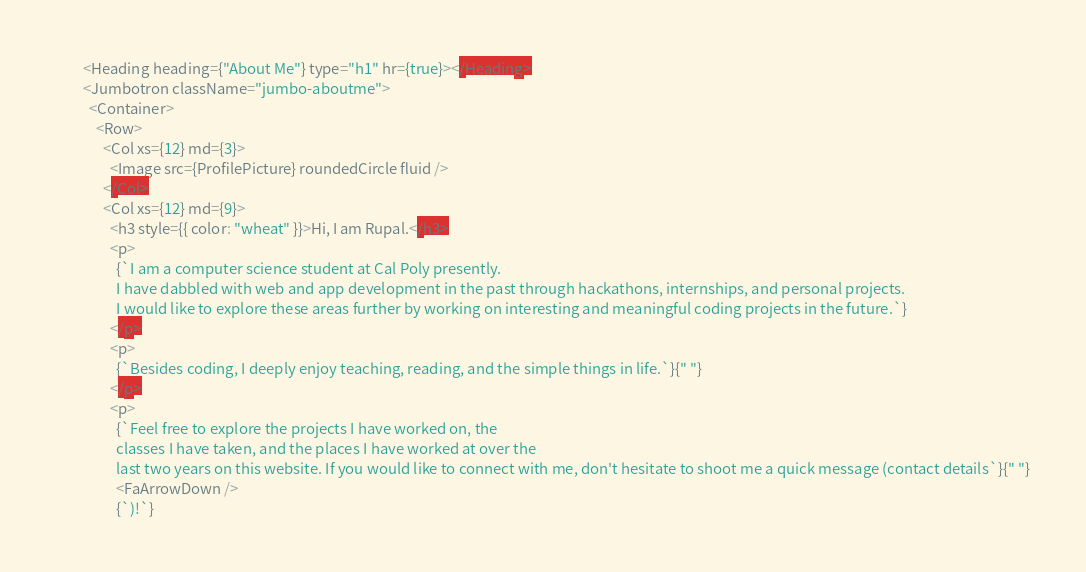<code> <loc_0><loc_0><loc_500><loc_500><_JavaScript_>        <Heading heading={"About Me"} type="h1" hr={true}></Heading>
        <Jumbotron className="jumbo-aboutme">
          <Container>
            <Row>
              <Col xs={12} md={3}>
                <Image src={ProfilePicture} roundedCircle fluid />
              </Col>
              <Col xs={12} md={9}>
                <h3 style={{ color: "wheat" }}>Hi, I am Rupal.</h3>
                <p>
                  {`I am a computer science student at Cal Poly presently. 
                  I have dabbled with web and app development in the past through hackathons, internships, and personal projects.
                  I would like to explore these areas further by working on interesting and meaningful coding projects in the future.`}
                </p>
                <p>
                  {`Besides coding, I deeply enjoy teaching, reading, and the simple things in life.`}{" "}
                </p>
                <p>
                  {`Feel free to explore the projects I have worked on, the
                  classes I have taken, and the places I have worked at over the
                  last two years on this website. If you would like to connect with me, don't hesitate to shoot me a quick message (contact details`}{" "}
                  <FaArrowDown />
                  {`)!`}</code> 